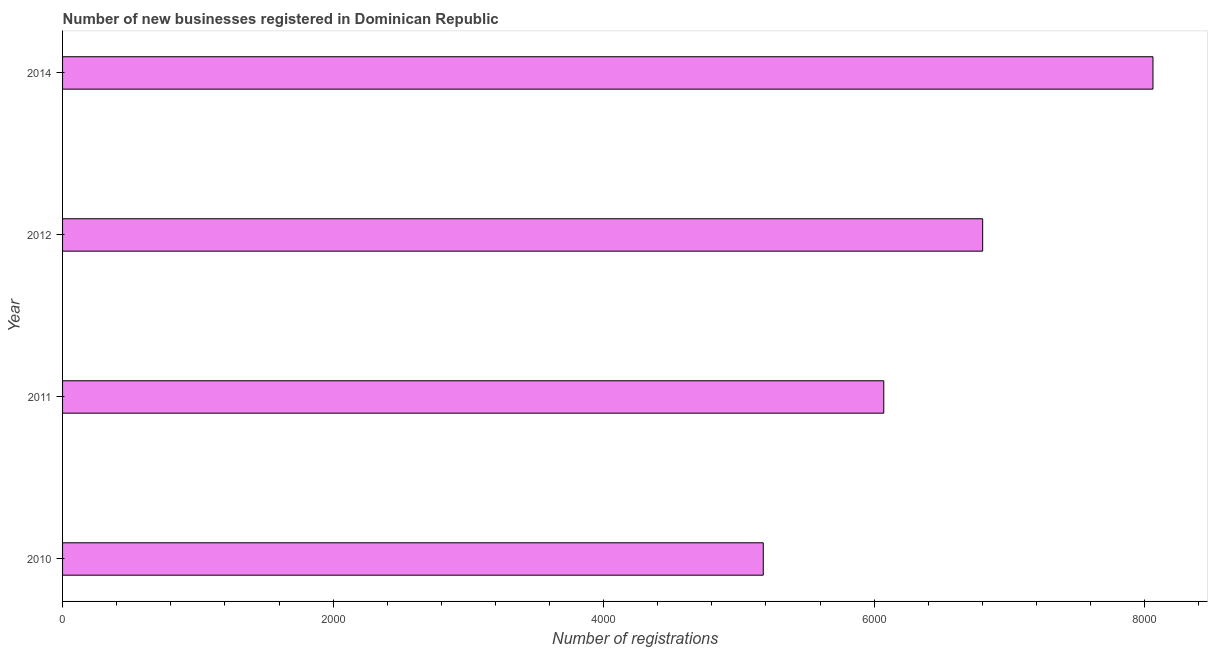Does the graph contain any zero values?
Your response must be concise. No. What is the title of the graph?
Make the answer very short. Number of new businesses registered in Dominican Republic. What is the label or title of the X-axis?
Offer a terse response. Number of registrations. What is the number of new business registrations in 2011?
Your answer should be very brief. 6071. Across all years, what is the maximum number of new business registrations?
Give a very brief answer. 8061. Across all years, what is the minimum number of new business registrations?
Your response must be concise. 5180. What is the sum of the number of new business registrations?
Your answer should be very brief. 2.61e+04. What is the difference between the number of new business registrations in 2012 and 2014?
Ensure brevity in your answer.  -1259. What is the average number of new business registrations per year?
Make the answer very short. 6528. What is the median number of new business registrations?
Your answer should be compact. 6436.5. Do a majority of the years between 2011 and 2012 (inclusive) have number of new business registrations greater than 2000 ?
Provide a succinct answer. Yes. What is the ratio of the number of new business registrations in 2010 to that in 2012?
Offer a terse response. 0.76. What is the difference between the highest and the second highest number of new business registrations?
Offer a terse response. 1259. What is the difference between the highest and the lowest number of new business registrations?
Give a very brief answer. 2881. How many bars are there?
Ensure brevity in your answer.  4. What is the difference between two consecutive major ticks on the X-axis?
Your answer should be compact. 2000. Are the values on the major ticks of X-axis written in scientific E-notation?
Your answer should be compact. No. What is the Number of registrations of 2010?
Your answer should be very brief. 5180. What is the Number of registrations in 2011?
Your answer should be compact. 6071. What is the Number of registrations in 2012?
Offer a very short reply. 6802. What is the Number of registrations in 2014?
Give a very brief answer. 8061. What is the difference between the Number of registrations in 2010 and 2011?
Your answer should be compact. -891. What is the difference between the Number of registrations in 2010 and 2012?
Give a very brief answer. -1622. What is the difference between the Number of registrations in 2010 and 2014?
Provide a short and direct response. -2881. What is the difference between the Number of registrations in 2011 and 2012?
Give a very brief answer. -731. What is the difference between the Number of registrations in 2011 and 2014?
Keep it short and to the point. -1990. What is the difference between the Number of registrations in 2012 and 2014?
Provide a short and direct response. -1259. What is the ratio of the Number of registrations in 2010 to that in 2011?
Provide a short and direct response. 0.85. What is the ratio of the Number of registrations in 2010 to that in 2012?
Offer a very short reply. 0.76. What is the ratio of the Number of registrations in 2010 to that in 2014?
Your answer should be compact. 0.64. What is the ratio of the Number of registrations in 2011 to that in 2012?
Provide a succinct answer. 0.89. What is the ratio of the Number of registrations in 2011 to that in 2014?
Provide a succinct answer. 0.75. What is the ratio of the Number of registrations in 2012 to that in 2014?
Keep it short and to the point. 0.84. 